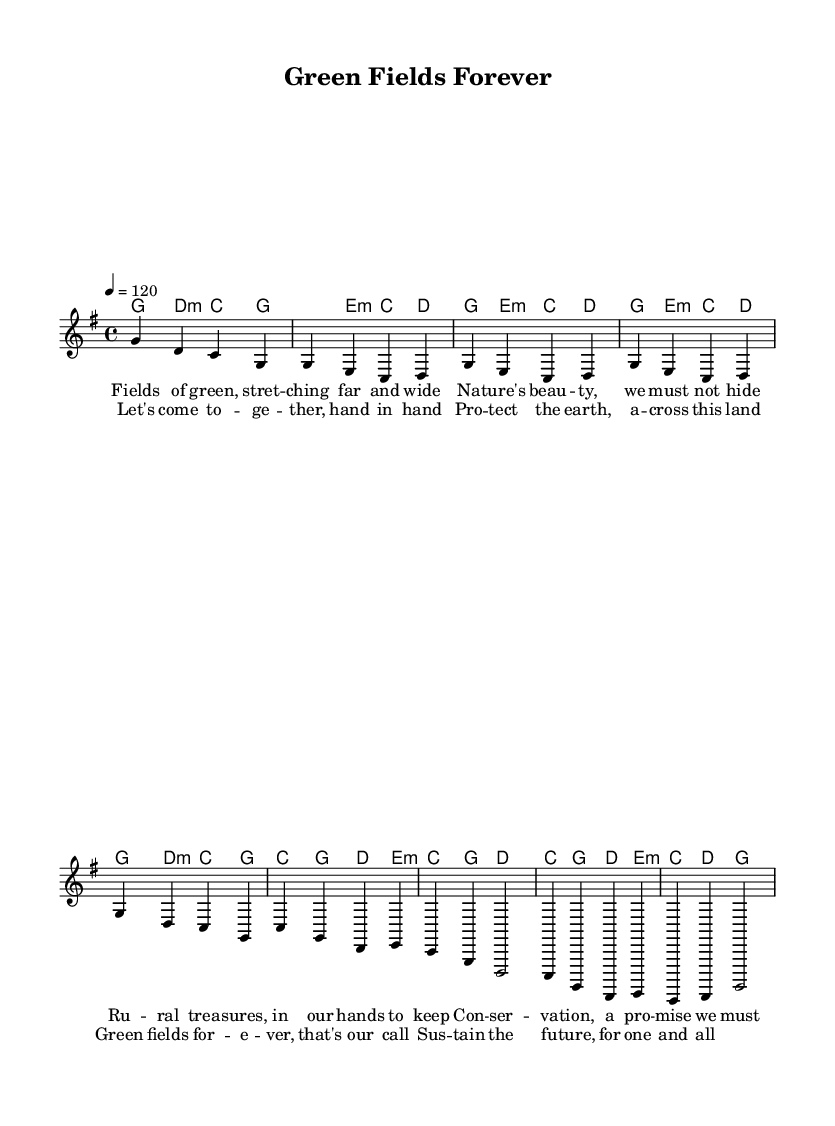What is the key signature of this music? The key signature is G major, which has one sharp (F#). This is indicated at the beginning of the sheet music.
Answer: G major What is the time signature of this music? The time signature is 4/4, meaning there are four beats in each measure and a quarter note receives one beat. This is clearly noted in the time signature notation at the start of the music.
Answer: 4/4 What is the tempo marking for this music? The tempo is marked as 120 beats per minute (4 = 120), which indicates the speed of the piece. This is found in the tempo directive at the beginning of the score.
Answer: 120 How many measures are in the verse section? There are four measures in the verse section, as indicated by the grouping of the notes in the verse part of the melody and the lyrics.
Answer: 4 What is the main theme addressed in the lyrics? The main theme is environmental conservation, as seen in phrases like "Conservation, a promise we must keep" and "Protect the earth." The lyrics reflect the intent to promote the preservation of nature.
Answer: Environmental conservation How does the chorus support the verse's message? The chorus emphasizes unity and action in pursuing environmental goals, evident in lines like "Let's come together, hand in hand" and "Sustain the future, for one and all." This connection reinforces the message presented in the verse through calls to action and community involvement.
Answer: Unity and action 